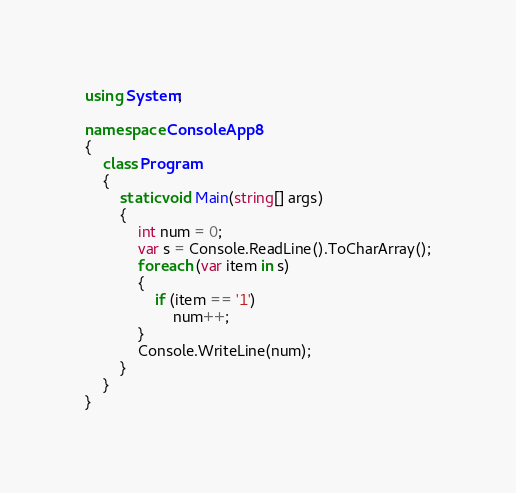Convert code to text. <code><loc_0><loc_0><loc_500><loc_500><_C#_>using System;

namespace ConsoleApp8
{
	class Program
	{
		static void Main(string[] args)
		{
			int num = 0;
			var s = Console.ReadLine().ToCharArray();
			foreach (var item in s)
			{
				if (item == '1')
					num++;
			}
			Console.WriteLine(num);
		}
	}
}
</code> 